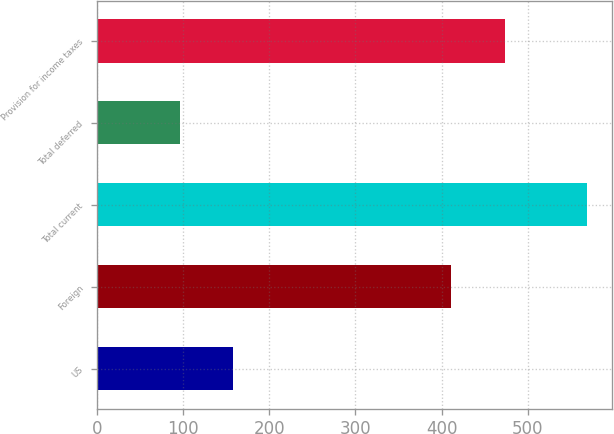Convert chart to OTSL. <chart><loc_0><loc_0><loc_500><loc_500><bar_chart><fcel>US<fcel>Foreign<fcel>Total current<fcel>Total deferred<fcel>Provision for income taxes<nl><fcel>158<fcel>411<fcel>569<fcel>96<fcel>473<nl></chart> 